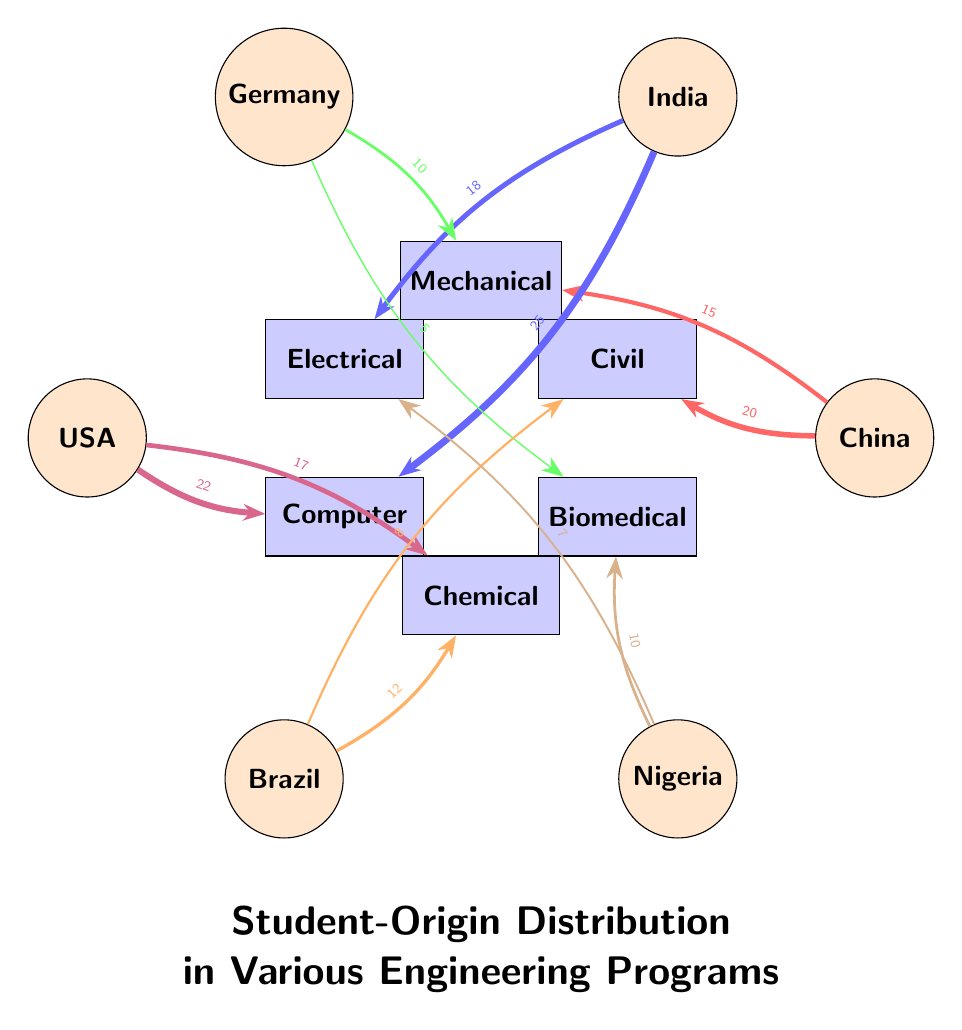What country has the highest number of students in Computer Science Engineering? By examining the links leading into the Computer Science Engineering node, the highest value is 25 from India.
Answer: India Which engineering program has students from Brazil? The diagram shows two connections from Brazil: one to Civil Engineering with a value of 8 and another to Chemical Engineering with a value of 12.
Answer: Civil Engineering and Chemical Engineering What is the total number of students from China in engineering programs? The sum of connections from China is 20 (Civil) + 15 (Mechanical) = 35.
Answer: 35 How many students from the United States are in Chemical Engineering? There is a direct connection from the United States to Chemical Engineering with a value of 17.
Answer: 17 Which country contributes the least to Biomedical Engineering? By examining the links, Germany contributes 5, Nigeria contributes 10, meaning Germany is the least.
Answer: Germany In which program do most students from India enroll? The links from India show 25 students for Computer Science Engineering and 18 for Electrical Engineering; hence Computer Science Engineering has the most.
Answer: Computer Science Engineering How many students from Nigeria study Electrical Engineering? The diagram indicates that Nigeria has 7 students in Electrical Engineering.
Answer: 7 Which country has the least representation in Mechanical Engineering? The connections show Germany with 10 and China with 15; hence Germany has the least representation in Mechanical Engineering.
Answer: Germany How many total edges are present in the diagram? Count the number of unique connections: there are 12 links.
Answer: 12 